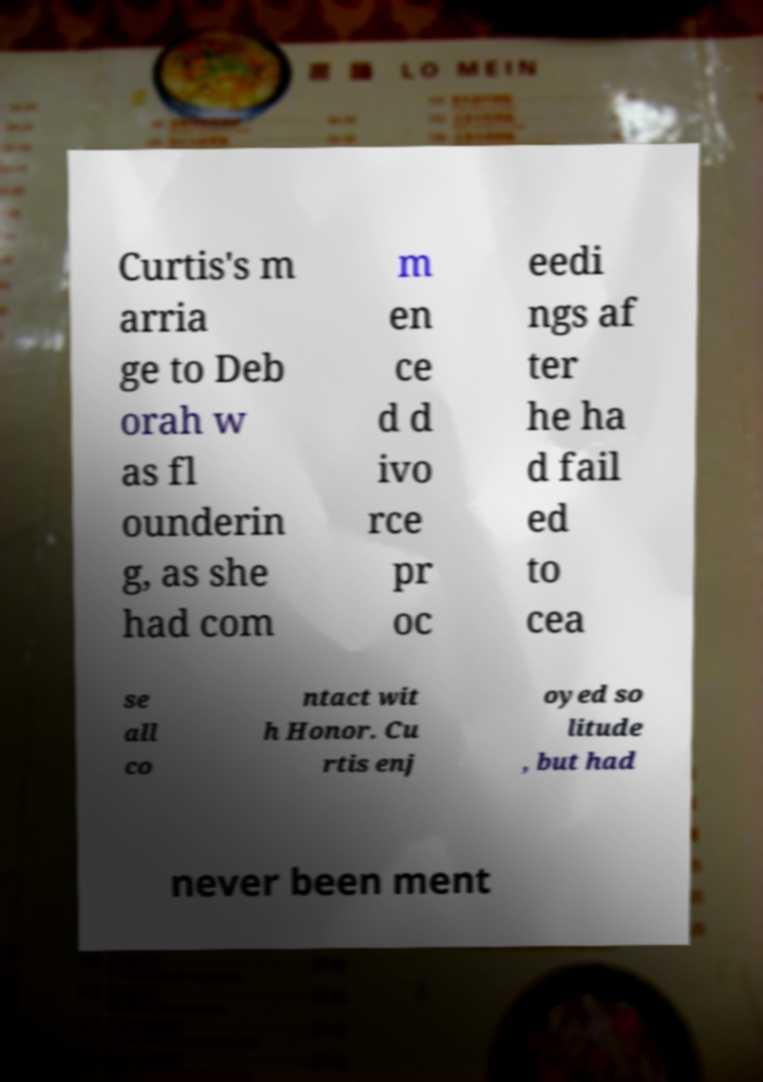Could you extract and type out the text from this image? Curtis's m arria ge to Deb orah w as fl ounderin g, as she had com m en ce d d ivo rce pr oc eedi ngs af ter he ha d fail ed to cea se all co ntact wit h Honor. Cu rtis enj oyed so litude , but had never been ment 